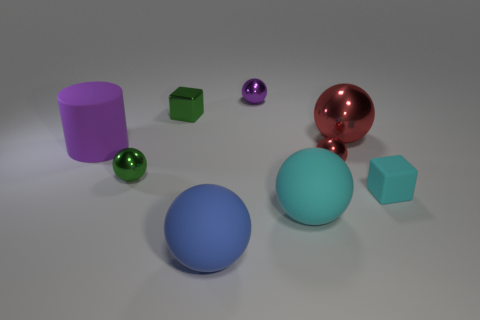Does the large rubber object behind the small cyan matte cube have the same shape as the tiny cyan matte thing?
Your answer should be very brief. No. Are there fewer matte objects than blue things?
Give a very brief answer. No. Is there any other thing of the same color as the big rubber cylinder?
Give a very brief answer. Yes. There is a tiny metallic thing on the right side of the large cyan matte sphere; what is its shape?
Your response must be concise. Sphere. There is a small matte thing; does it have the same color as the block behind the small cyan rubber thing?
Keep it short and to the point. No. Is the number of tiny metal things that are left of the cyan matte sphere the same as the number of tiny balls to the left of the purple metal ball?
Offer a very short reply. No. What number of other things are there of the same size as the cyan rubber sphere?
Your response must be concise. 3. What is the size of the cyan matte sphere?
Offer a terse response. Large. Is the green cube made of the same material as the purple thing that is on the left side of the big blue rubber ball?
Give a very brief answer. No. Is there a small green metallic object that has the same shape as the small red object?
Provide a succinct answer. Yes. 